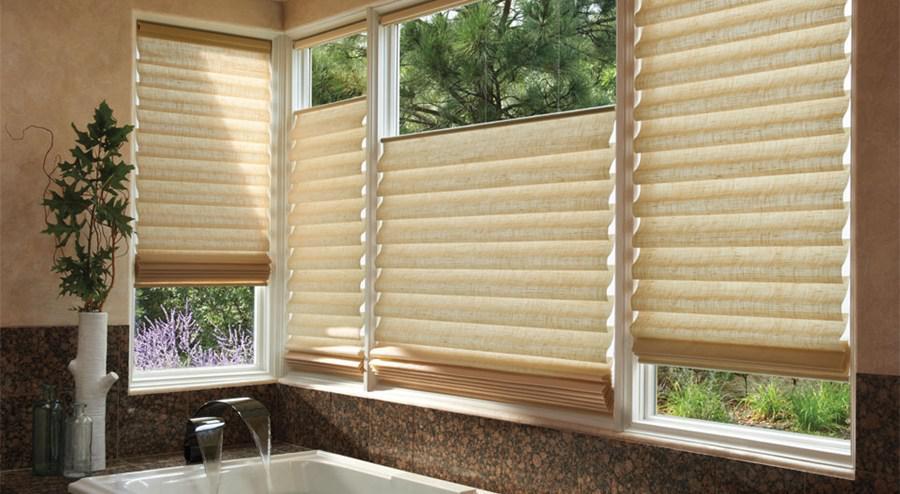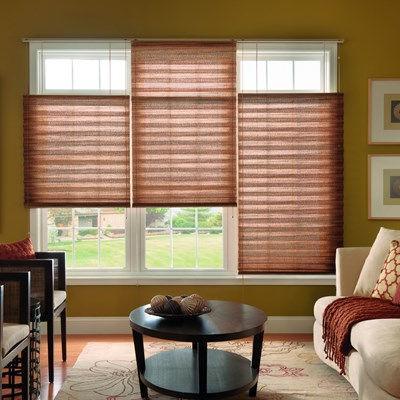The first image is the image on the left, the second image is the image on the right. Assess this claim about the two images: "Four sets of blinds are partially opened at the top of the window.". Correct or not? Answer yes or no. Yes. The first image is the image on the left, the second image is the image on the right. For the images shown, is this caption "There are at least ten window panes." true? Answer yes or no. No. 